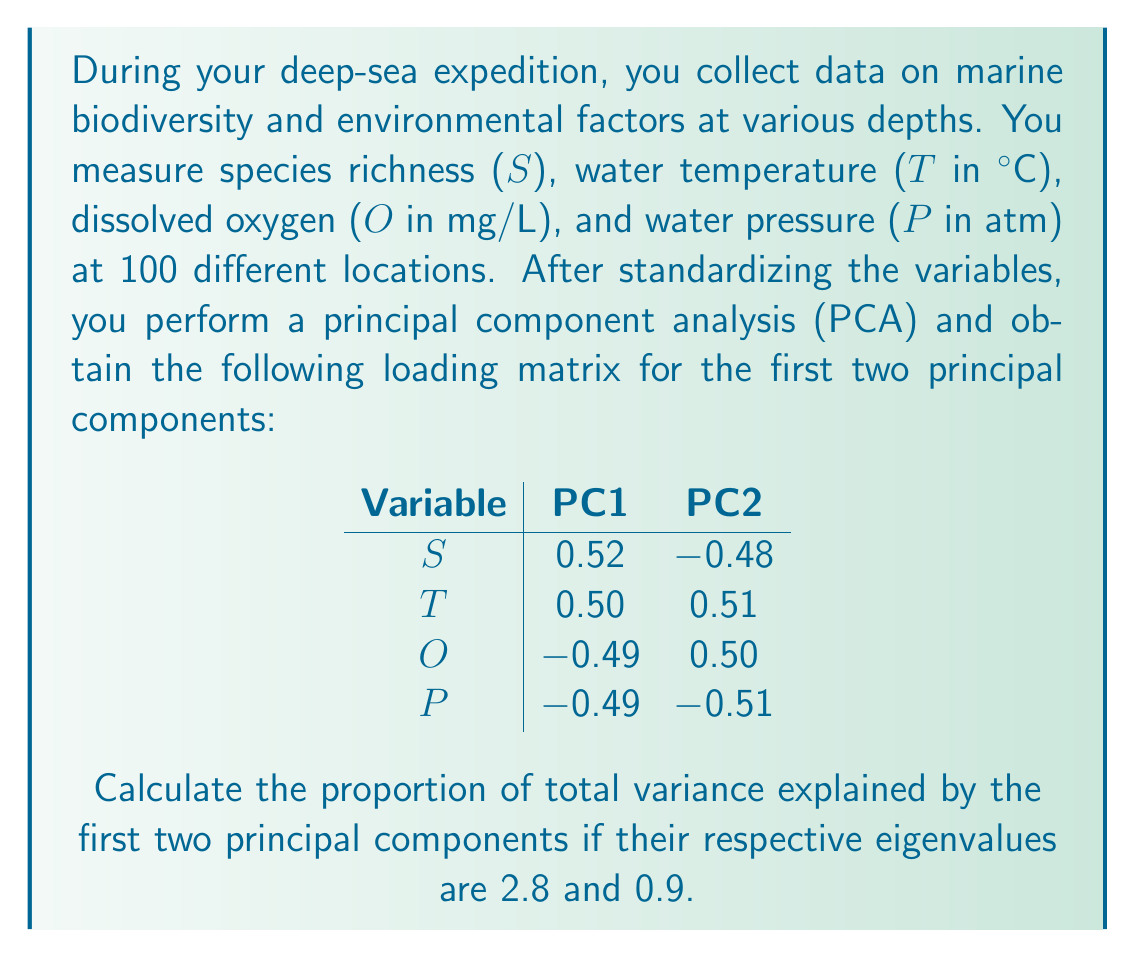Provide a solution to this math problem. To solve this problem, we need to follow these steps:

1) First, recall that in PCA, the total variance is equal to the number of variables when using standardized data. In this case, we have 4 variables (S, T, O, and P), so the total variance is 4.

2) The variance explained by each principal component is equal to its eigenvalue. We are given:
   - Eigenvalue of PC1 = 2.8
   - Eigenvalue of PC2 = 0.9

3) To calculate the proportion of variance explained by PC1 and PC2 combined, we need to:
   a) Sum the eigenvalues of PC1 and PC2
   b) Divide this sum by the total variance

4) Let's perform the calculation:
   
   Sum of eigenvalues = 2.8 + 0.9 = 3.7
   
   Proportion of variance explained = $\frac{3.7}{4} = 0.925$

5) To express this as a percentage, we multiply by 100:

   0.925 * 100 = 92.5%

Therefore, the first two principal components explain 92.5% of the total variance in the data.

This high percentage indicates that these two components capture most of the variation in your deep-sea biodiversity and environmental data, allowing you to effectively reduce the dimensionality of your dataset while retaining most of the information.
Answer: The proportion of total variance explained by the first two principal components is 0.925 or 92.5%. 